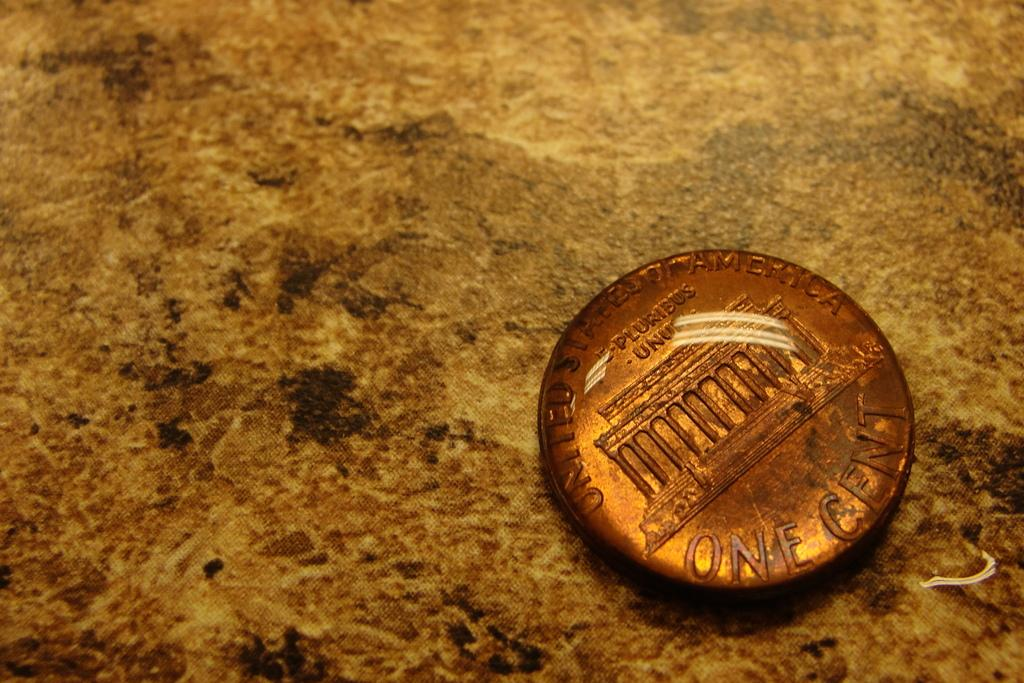<image>
Write a terse but informative summary of the picture. An old one cent penny from the United States of America. 